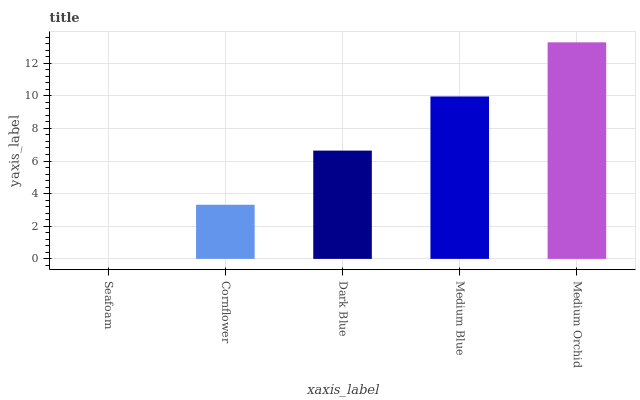Is Seafoam the minimum?
Answer yes or no. Yes. Is Medium Orchid the maximum?
Answer yes or no. Yes. Is Cornflower the minimum?
Answer yes or no. No. Is Cornflower the maximum?
Answer yes or no. No. Is Cornflower greater than Seafoam?
Answer yes or no. Yes. Is Seafoam less than Cornflower?
Answer yes or no. Yes. Is Seafoam greater than Cornflower?
Answer yes or no. No. Is Cornflower less than Seafoam?
Answer yes or no. No. Is Dark Blue the high median?
Answer yes or no. Yes. Is Dark Blue the low median?
Answer yes or no. Yes. Is Cornflower the high median?
Answer yes or no. No. Is Medium Blue the low median?
Answer yes or no. No. 